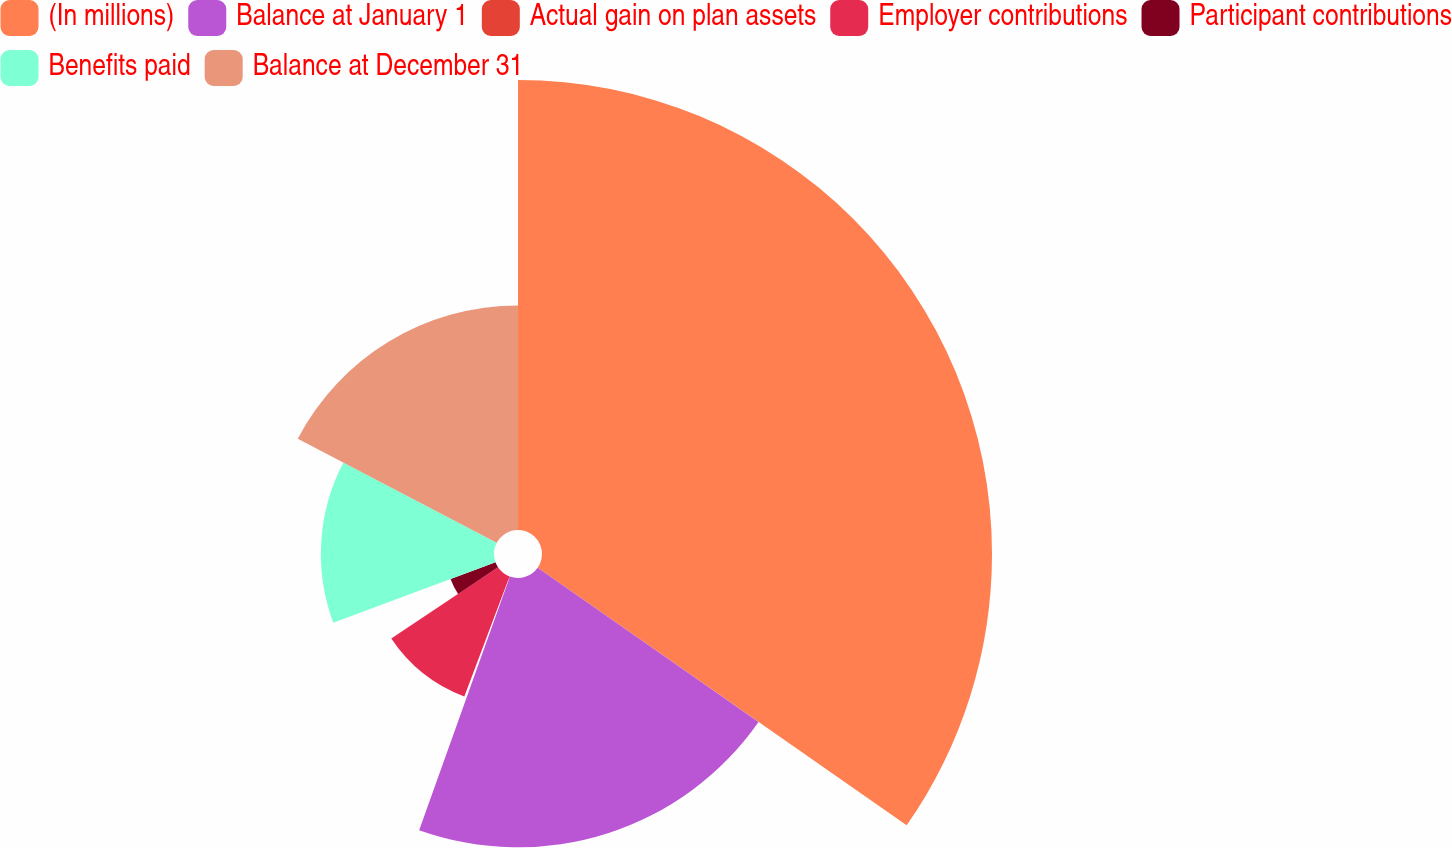<chart> <loc_0><loc_0><loc_500><loc_500><pie_chart><fcel>(In millions)<fcel>Balance at January 1<fcel>Actual gain on plan assets<fcel>Employer contributions<fcel>Participant contributions<fcel>Benefits paid<fcel>Balance at December 31<nl><fcel>34.7%<fcel>20.77%<fcel>0.26%<fcel>9.9%<fcel>3.7%<fcel>13.35%<fcel>17.32%<nl></chart> 